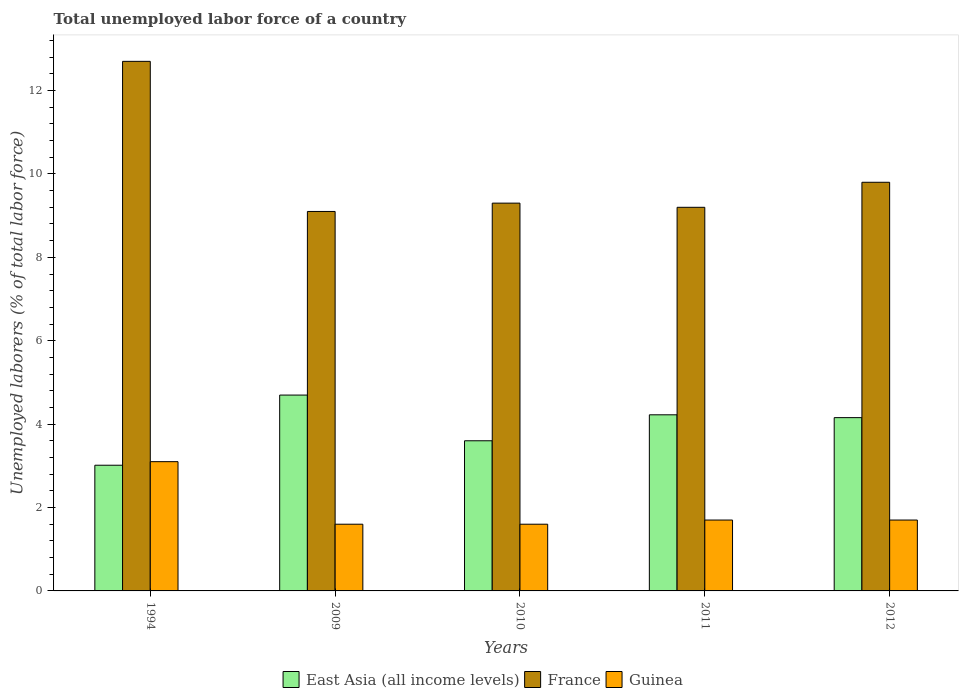What is the total unemployed labor force in France in 2011?
Keep it short and to the point. 9.2. Across all years, what is the maximum total unemployed labor force in France?
Provide a short and direct response. 12.7. Across all years, what is the minimum total unemployed labor force in France?
Keep it short and to the point. 9.1. In which year was the total unemployed labor force in Guinea minimum?
Your answer should be compact. 2009. What is the total total unemployed labor force in Guinea in the graph?
Provide a short and direct response. 9.7. What is the difference between the total unemployed labor force in France in 1994 and that in 2011?
Make the answer very short. 3.5. What is the difference between the total unemployed labor force in East Asia (all income levels) in 2012 and the total unemployed labor force in Guinea in 1994?
Keep it short and to the point. 1.06. What is the average total unemployed labor force in Guinea per year?
Make the answer very short. 1.94. In the year 2012, what is the difference between the total unemployed labor force in Guinea and total unemployed labor force in France?
Provide a short and direct response. -8.1. In how many years, is the total unemployed labor force in France greater than 10 %?
Ensure brevity in your answer.  1. What is the ratio of the total unemployed labor force in Guinea in 1994 to that in 2010?
Keep it short and to the point. 1.94. Is the total unemployed labor force in Guinea in 1994 less than that in 2009?
Give a very brief answer. No. Is the difference between the total unemployed labor force in Guinea in 2009 and 2010 greater than the difference between the total unemployed labor force in France in 2009 and 2010?
Your response must be concise. Yes. What is the difference between the highest and the second highest total unemployed labor force in France?
Make the answer very short. 2.9. What is the difference between the highest and the lowest total unemployed labor force in France?
Provide a short and direct response. 3.6. Is the sum of the total unemployed labor force in Guinea in 2009 and 2010 greater than the maximum total unemployed labor force in East Asia (all income levels) across all years?
Your response must be concise. No. What does the 3rd bar from the left in 2009 represents?
Provide a short and direct response. Guinea. What does the 3rd bar from the right in 2010 represents?
Your answer should be compact. East Asia (all income levels). Is it the case that in every year, the sum of the total unemployed labor force in France and total unemployed labor force in East Asia (all income levels) is greater than the total unemployed labor force in Guinea?
Provide a succinct answer. Yes. What is the difference between two consecutive major ticks on the Y-axis?
Keep it short and to the point. 2. Where does the legend appear in the graph?
Your response must be concise. Bottom center. How are the legend labels stacked?
Provide a succinct answer. Horizontal. What is the title of the graph?
Your response must be concise. Total unemployed labor force of a country. What is the label or title of the X-axis?
Offer a very short reply. Years. What is the label or title of the Y-axis?
Give a very brief answer. Unemployed laborers (% of total labor force). What is the Unemployed laborers (% of total labor force) in East Asia (all income levels) in 1994?
Give a very brief answer. 3.01. What is the Unemployed laborers (% of total labor force) in France in 1994?
Offer a very short reply. 12.7. What is the Unemployed laborers (% of total labor force) in Guinea in 1994?
Offer a very short reply. 3.1. What is the Unemployed laborers (% of total labor force) of East Asia (all income levels) in 2009?
Your answer should be very brief. 4.7. What is the Unemployed laborers (% of total labor force) of France in 2009?
Provide a short and direct response. 9.1. What is the Unemployed laborers (% of total labor force) of Guinea in 2009?
Offer a terse response. 1.6. What is the Unemployed laborers (% of total labor force) in East Asia (all income levels) in 2010?
Your response must be concise. 3.6. What is the Unemployed laborers (% of total labor force) of France in 2010?
Offer a terse response. 9.3. What is the Unemployed laborers (% of total labor force) of Guinea in 2010?
Ensure brevity in your answer.  1.6. What is the Unemployed laborers (% of total labor force) in East Asia (all income levels) in 2011?
Provide a short and direct response. 4.22. What is the Unemployed laborers (% of total labor force) of France in 2011?
Provide a short and direct response. 9.2. What is the Unemployed laborers (% of total labor force) in Guinea in 2011?
Offer a terse response. 1.7. What is the Unemployed laborers (% of total labor force) of East Asia (all income levels) in 2012?
Your response must be concise. 4.16. What is the Unemployed laborers (% of total labor force) in France in 2012?
Provide a short and direct response. 9.8. What is the Unemployed laborers (% of total labor force) in Guinea in 2012?
Keep it short and to the point. 1.7. Across all years, what is the maximum Unemployed laborers (% of total labor force) in East Asia (all income levels)?
Offer a terse response. 4.7. Across all years, what is the maximum Unemployed laborers (% of total labor force) of France?
Give a very brief answer. 12.7. Across all years, what is the maximum Unemployed laborers (% of total labor force) in Guinea?
Your answer should be compact. 3.1. Across all years, what is the minimum Unemployed laborers (% of total labor force) in East Asia (all income levels)?
Give a very brief answer. 3.01. Across all years, what is the minimum Unemployed laborers (% of total labor force) in France?
Make the answer very short. 9.1. Across all years, what is the minimum Unemployed laborers (% of total labor force) in Guinea?
Make the answer very short. 1.6. What is the total Unemployed laborers (% of total labor force) in East Asia (all income levels) in the graph?
Offer a terse response. 19.69. What is the total Unemployed laborers (% of total labor force) in France in the graph?
Ensure brevity in your answer.  50.1. What is the difference between the Unemployed laborers (% of total labor force) in East Asia (all income levels) in 1994 and that in 2009?
Your response must be concise. -1.68. What is the difference between the Unemployed laborers (% of total labor force) in France in 1994 and that in 2009?
Make the answer very short. 3.6. What is the difference between the Unemployed laborers (% of total labor force) in East Asia (all income levels) in 1994 and that in 2010?
Provide a succinct answer. -0.59. What is the difference between the Unemployed laborers (% of total labor force) of France in 1994 and that in 2010?
Your response must be concise. 3.4. What is the difference between the Unemployed laborers (% of total labor force) in Guinea in 1994 and that in 2010?
Make the answer very short. 1.5. What is the difference between the Unemployed laborers (% of total labor force) of East Asia (all income levels) in 1994 and that in 2011?
Offer a very short reply. -1.21. What is the difference between the Unemployed laborers (% of total labor force) in Guinea in 1994 and that in 2011?
Your answer should be very brief. 1.4. What is the difference between the Unemployed laborers (% of total labor force) in East Asia (all income levels) in 1994 and that in 2012?
Your response must be concise. -1.14. What is the difference between the Unemployed laborers (% of total labor force) in France in 1994 and that in 2012?
Ensure brevity in your answer.  2.9. What is the difference between the Unemployed laborers (% of total labor force) in Guinea in 1994 and that in 2012?
Your answer should be compact. 1.4. What is the difference between the Unemployed laborers (% of total labor force) of East Asia (all income levels) in 2009 and that in 2010?
Provide a succinct answer. 1.1. What is the difference between the Unemployed laborers (% of total labor force) of France in 2009 and that in 2010?
Offer a very short reply. -0.2. What is the difference between the Unemployed laborers (% of total labor force) of East Asia (all income levels) in 2009 and that in 2011?
Your response must be concise. 0.47. What is the difference between the Unemployed laborers (% of total labor force) of France in 2009 and that in 2011?
Offer a terse response. -0.1. What is the difference between the Unemployed laborers (% of total labor force) in East Asia (all income levels) in 2009 and that in 2012?
Keep it short and to the point. 0.54. What is the difference between the Unemployed laborers (% of total labor force) of Guinea in 2009 and that in 2012?
Your response must be concise. -0.1. What is the difference between the Unemployed laborers (% of total labor force) of East Asia (all income levels) in 2010 and that in 2011?
Offer a terse response. -0.62. What is the difference between the Unemployed laborers (% of total labor force) in France in 2010 and that in 2011?
Your answer should be compact. 0.1. What is the difference between the Unemployed laborers (% of total labor force) of Guinea in 2010 and that in 2011?
Provide a succinct answer. -0.1. What is the difference between the Unemployed laborers (% of total labor force) of East Asia (all income levels) in 2010 and that in 2012?
Provide a short and direct response. -0.55. What is the difference between the Unemployed laborers (% of total labor force) of France in 2010 and that in 2012?
Offer a very short reply. -0.5. What is the difference between the Unemployed laborers (% of total labor force) of East Asia (all income levels) in 2011 and that in 2012?
Your response must be concise. 0.07. What is the difference between the Unemployed laborers (% of total labor force) of Guinea in 2011 and that in 2012?
Make the answer very short. 0. What is the difference between the Unemployed laborers (% of total labor force) of East Asia (all income levels) in 1994 and the Unemployed laborers (% of total labor force) of France in 2009?
Your answer should be very brief. -6.09. What is the difference between the Unemployed laborers (% of total labor force) in East Asia (all income levels) in 1994 and the Unemployed laborers (% of total labor force) in Guinea in 2009?
Offer a terse response. 1.41. What is the difference between the Unemployed laborers (% of total labor force) of East Asia (all income levels) in 1994 and the Unemployed laborers (% of total labor force) of France in 2010?
Offer a very short reply. -6.29. What is the difference between the Unemployed laborers (% of total labor force) in East Asia (all income levels) in 1994 and the Unemployed laborers (% of total labor force) in Guinea in 2010?
Provide a succinct answer. 1.41. What is the difference between the Unemployed laborers (% of total labor force) in East Asia (all income levels) in 1994 and the Unemployed laborers (% of total labor force) in France in 2011?
Provide a short and direct response. -6.19. What is the difference between the Unemployed laborers (% of total labor force) of East Asia (all income levels) in 1994 and the Unemployed laborers (% of total labor force) of Guinea in 2011?
Provide a short and direct response. 1.31. What is the difference between the Unemployed laborers (% of total labor force) in East Asia (all income levels) in 1994 and the Unemployed laborers (% of total labor force) in France in 2012?
Your response must be concise. -6.79. What is the difference between the Unemployed laborers (% of total labor force) in East Asia (all income levels) in 1994 and the Unemployed laborers (% of total labor force) in Guinea in 2012?
Offer a terse response. 1.31. What is the difference between the Unemployed laborers (% of total labor force) of France in 1994 and the Unemployed laborers (% of total labor force) of Guinea in 2012?
Provide a succinct answer. 11. What is the difference between the Unemployed laborers (% of total labor force) of East Asia (all income levels) in 2009 and the Unemployed laborers (% of total labor force) of France in 2010?
Offer a terse response. -4.6. What is the difference between the Unemployed laborers (% of total labor force) of East Asia (all income levels) in 2009 and the Unemployed laborers (% of total labor force) of Guinea in 2010?
Your answer should be very brief. 3.1. What is the difference between the Unemployed laborers (% of total labor force) of East Asia (all income levels) in 2009 and the Unemployed laborers (% of total labor force) of France in 2011?
Offer a very short reply. -4.5. What is the difference between the Unemployed laborers (% of total labor force) in East Asia (all income levels) in 2009 and the Unemployed laborers (% of total labor force) in Guinea in 2011?
Your response must be concise. 3. What is the difference between the Unemployed laborers (% of total labor force) of France in 2009 and the Unemployed laborers (% of total labor force) of Guinea in 2011?
Your answer should be very brief. 7.4. What is the difference between the Unemployed laborers (% of total labor force) of East Asia (all income levels) in 2009 and the Unemployed laborers (% of total labor force) of France in 2012?
Keep it short and to the point. -5.1. What is the difference between the Unemployed laborers (% of total labor force) of East Asia (all income levels) in 2009 and the Unemployed laborers (% of total labor force) of Guinea in 2012?
Offer a very short reply. 3. What is the difference between the Unemployed laborers (% of total labor force) of France in 2009 and the Unemployed laborers (% of total labor force) of Guinea in 2012?
Make the answer very short. 7.4. What is the difference between the Unemployed laborers (% of total labor force) in East Asia (all income levels) in 2010 and the Unemployed laborers (% of total labor force) in France in 2011?
Your response must be concise. -5.6. What is the difference between the Unemployed laborers (% of total labor force) in East Asia (all income levels) in 2010 and the Unemployed laborers (% of total labor force) in Guinea in 2011?
Your response must be concise. 1.9. What is the difference between the Unemployed laborers (% of total labor force) of France in 2010 and the Unemployed laborers (% of total labor force) of Guinea in 2011?
Your response must be concise. 7.6. What is the difference between the Unemployed laborers (% of total labor force) in East Asia (all income levels) in 2010 and the Unemployed laborers (% of total labor force) in France in 2012?
Your response must be concise. -6.2. What is the difference between the Unemployed laborers (% of total labor force) of East Asia (all income levels) in 2010 and the Unemployed laborers (% of total labor force) of Guinea in 2012?
Provide a succinct answer. 1.9. What is the difference between the Unemployed laborers (% of total labor force) in France in 2010 and the Unemployed laborers (% of total labor force) in Guinea in 2012?
Give a very brief answer. 7.6. What is the difference between the Unemployed laborers (% of total labor force) in East Asia (all income levels) in 2011 and the Unemployed laborers (% of total labor force) in France in 2012?
Offer a terse response. -5.58. What is the difference between the Unemployed laborers (% of total labor force) in East Asia (all income levels) in 2011 and the Unemployed laborers (% of total labor force) in Guinea in 2012?
Your answer should be compact. 2.52. What is the difference between the Unemployed laborers (% of total labor force) of France in 2011 and the Unemployed laborers (% of total labor force) of Guinea in 2012?
Provide a short and direct response. 7.5. What is the average Unemployed laborers (% of total labor force) of East Asia (all income levels) per year?
Provide a succinct answer. 3.94. What is the average Unemployed laborers (% of total labor force) in France per year?
Make the answer very short. 10.02. What is the average Unemployed laborers (% of total labor force) in Guinea per year?
Provide a short and direct response. 1.94. In the year 1994, what is the difference between the Unemployed laborers (% of total labor force) in East Asia (all income levels) and Unemployed laborers (% of total labor force) in France?
Your answer should be compact. -9.69. In the year 1994, what is the difference between the Unemployed laborers (% of total labor force) in East Asia (all income levels) and Unemployed laborers (% of total labor force) in Guinea?
Give a very brief answer. -0.09. In the year 1994, what is the difference between the Unemployed laborers (% of total labor force) of France and Unemployed laborers (% of total labor force) of Guinea?
Make the answer very short. 9.6. In the year 2009, what is the difference between the Unemployed laborers (% of total labor force) of East Asia (all income levels) and Unemployed laborers (% of total labor force) of France?
Provide a succinct answer. -4.4. In the year 2009, what is the difference between the Unemployed laborers (% of total labor force) of East Asia (all income levels) and Unemployed laborers (% of total labor force) of Guinea?
Make the answer very short. 3.1. In the year 2009, what is the difference between the Unemployed laborers (% of total labor force) in France and Unemployed laborers (% of total labor force) in Guinea?
Give a very brief answer. 7.5. In the year 2010, what is the difference between the Unemployed laborers (% of total labor force) of East Asia (all income levels) and Unemployed laborers (% of total labor force) of France?
Give a very brief answer. -5.7. In the year 2010, what is the difference between the Unemployed laborers (% of total labor force) in East Asia (all income levels) and Unemployed laborers (% of total labor force) in Guinea?
Provide a short and direct response. 2. In the year 2011, what is the difference between the Unemployed laborers (% of total labor force) in East Asia (all income levels) and Unemployed laborers (% of total labor force) in France?
Your response must be concise. -4.98. In the year 2011, what is the difference between the Unemployed laborers (% of total labor force) in East Asia (all income levels) and Unemployed laborers (% of total labor force) in Guinea?
Your response must be concise. 2.52. In the year 2012, what is the difference between the Unemployed laborers (% of total labor force) in East Asia (all income levels) and Unemployed laborers (% of total labor force) in France?
Keep it short and to the point. -5.64. In the year 2012, what is the difference between the Unemployed laborers (% of total labor force) of East Asia (all income levels) and Unemployed laborers (% of total labor force) of Guinea?
Your response must be concise. 2.46. What is the ratio of the Unemployed laborers (% of total labor force) in East Asia (all income levels) in 1994 to that in 2009?
Offer a terse response. 0.64. What is the ratio of the Unemployed laborers (% of total labor force) of France in 1994 to that in 2009?
Your answer should be very brief. 1.4. What is the ratio of the Unemployed laborers (% of total labor force) of Guinea in 1994 to that in 2009?
Make the answer very short. 1.94. What is the ratio of the Unemployed laborers (% of total labor force) of East Asia (all income levels) in 1994 to that in 2010?
Keep it short and to the point. 0.84. What is the ratio of the Unemployed laborers (% of total labor force) in France in 1994 to that in 2010?
Provide a succinct answer. 1.37. What is the ratio of the Unemployed laborers (% of total labor force) of Guinea in 1994 to that in 2010?
Your answer should be compact. 1.94. What is the ratio of the Unemployed laborers (% of total labor force) in East Asia (all income levels) in 1994 to that in 2011?
Ensure brevity in your answer.  0.71. What is the ratio of the Unemployed laborers (% of total labor force) of France in 1994 to that in 2011?
Offer a terse response. 1.38. What is the ratio of the Unemployed laborers (% of total labor force) of Guinea in 1994 to that in 2011?
Your response must be concise. 1.82. What is the ratio of the Unemployed laborers (% of total labor force) in East Asia (all income levels) in 1994 to that in 2012?
Provide a succinct answer. 0.73. What is the ratio of the Unemployed laborers (% of total labor force) in France in 1994 to that in 2012?
Offer a very short reply. 1.3. What is the ratio of the Unemployed laborers (% of total labor force) of Guinea in 1994 to that in 2012?
Your answer should be compact. 1.82. What is the ratio of the Unemployed laborers (% of total labor force) of East Asia (all income levels) in 2009 to that in 2010?
Your answer should be compact. 1.3. What is the ratio of the Unemployed laborers (% of total labor force) in France in 2009 to that in 2010?
Your answer should be compact. 0.98. What is the ratio of the Unemployed laborers (% of total labor force) of Guinea in 2009 to that in 2010?
Make the answer very short. 1. What is the ratio of the Unemployed laborers (% of total labor force) in East Asia (all income levels) in 2009 to that in 2011?
Provide a succinct answer. 1.11. What is the ratio of the Unemployed laborers (% of total labor force) in France in 2009 to that in 2011?
Provide a succinct answer. 0.99. What is the ratio of the Unemployed laborers (% of total labor force) in East Asia (all income levels) in 2009 to that in 2012?
Provide a succinct answer. 1.13. What is the ratio of the Unemployed laborers (% of total labor force) in France in 2009 to that in 2012?
Offer a terse response. 0.93. What is the ratio of the Unemployed laborers (% of total labor force) of East Asia (all income levels) in 2010 to that in 2011?
Offer a terse response. 0.85. What is the ratio of the Unemployed laborers (% of total labor force) of France in 2010 to that in 2011?
Keep it short and to the point. 1.01. What is the ratio of the Unemployed laborers (% of total labor force) in East Asia (all income levels) in 2010 to that in 2012?
Your response must be concise. 0.87. What is the ratio of the Unemployed laborers (% of total labor force) in France in 2010 to that in 2012?
Offer a very short reply. 0.95. What is the ratio of the Unemployed laborers (% of total labor force) of Guinea in 2010 to that in 2012?
Your response must be concise. 0.94. What is the ratio of the Unemployed laborers (% of total labor force) of East Asia (all income levels) in 2011 to that in 2012?
Your answer should be compact. 1.02. What is the ratio of the Unemployed laborers (% of total labor force) of France in 2011 to that in 2012?
Ensure brevity in your answer.  0.94. What is the ratio of the Unemployed laborers (% of total labor force) of Guinea in 2011 to that in 2012?
Offer a terse response. 1. What is the difference between the highest and the second highest Unemployed laborers (% of total labor force) in East Asia (all income levels)?
Your answer should be compact. 0.47. What is the difference between the highest and the second highest Unemployed laborers (% of total labor force) of Guinea?
Keep it short and to the point. 1.4. What is the difference between the highest and the lowest Unemployed laborers (% of total labor force) of East Asia (all income levels)?
Your answer should be very brief. 1.68. What is the difference between the highest and the lowest Unemployed laborers (% of total labor force) of France?
Provide a succinct answer. 3.6. 